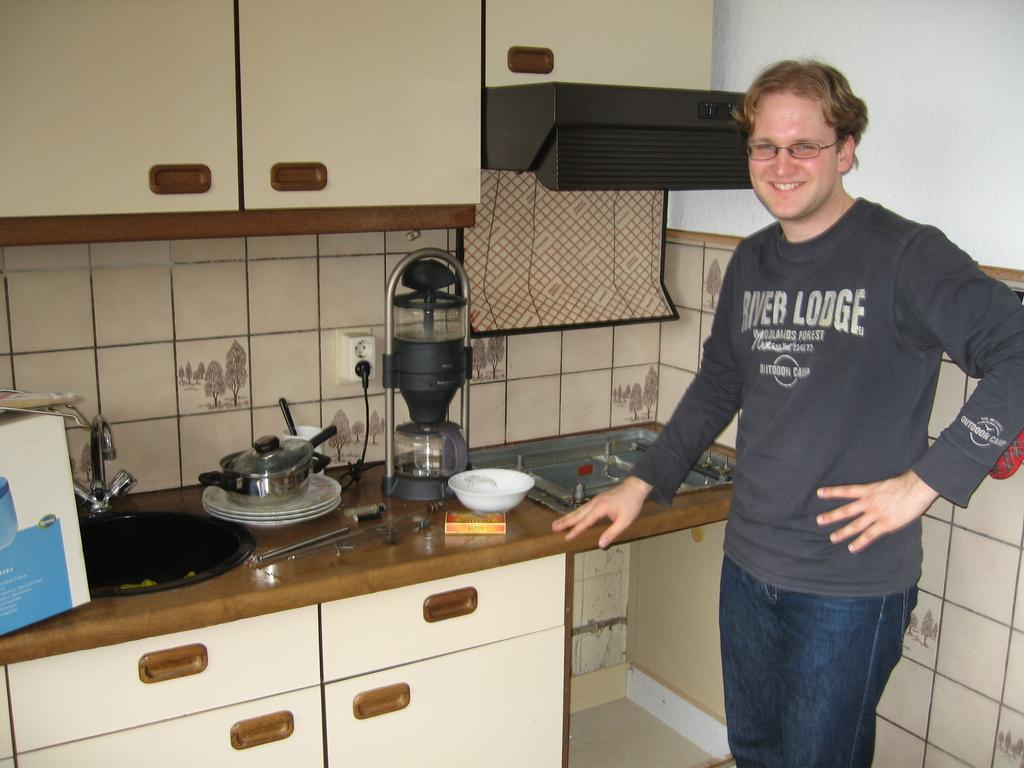<image>
Describe the image concisely. A man in the kitchen wearing a River Lodge shirt and smiling 